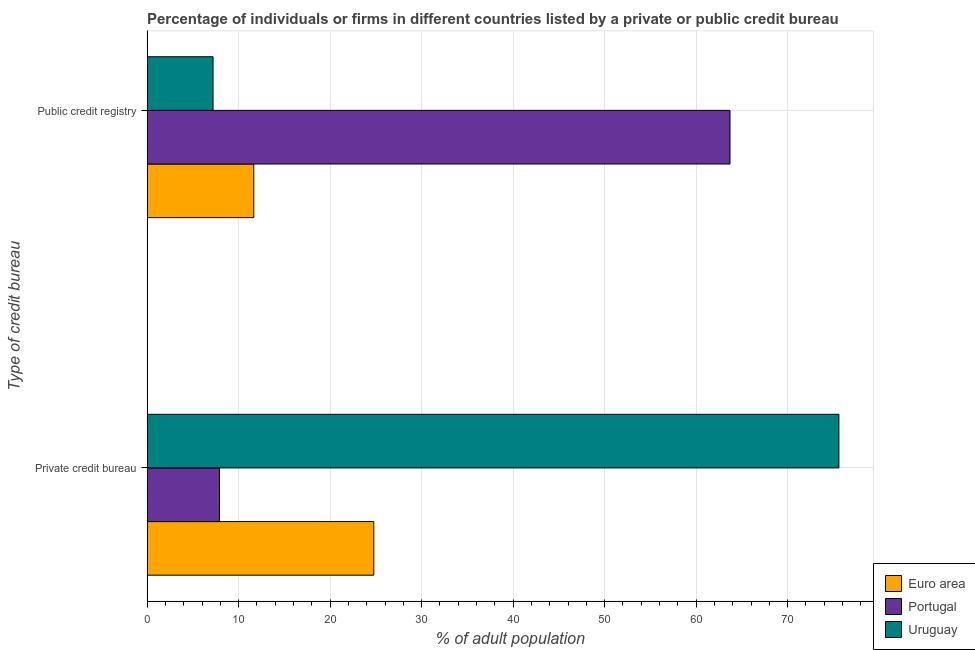Are the number of bars per tick equal to the number of legend labels?
Offer a very short reply. Yes. How many bars are there on the 1st tick from the top?
Make the answer very short. 3. What is the label of the 1st group of bars from the top?
Your answer should be very brief. Public credit registry. What is the percentage of firms listed by public credit bureau in Portugal?
Make the answer very short. 63.7. Across all countries, what is the maximum percentage of firms listed by private credit bureau?
Provide a short and direct response. 75.6. Across all countries, what is the minimum percentage of firms listed by private credit bureau?
Your answer should be compact. 7.9. In which country was the percentage of firms listed by private credit bureau maximum?
Make the answer very short. Uruguay. In which country was the percentage of firms listed by public credit bureau minimum?
Keep it short and to the point. Uruguay. What is the total percentage of firms listed by private credit bureau in the graph?
Ensure brevity in your answer.  108.27. What is the difference between the percentage of firms listed by private credit bureau in Euro area and that in Portugal?
Your response must be concise. 16.87. What is the difference between the percentage of firms listed by public credit bureau in Portugal and the percentage of firms listed by private credit bureau in Euro area?
Your answer should be compact. 38.93. What is the average percentage of firms listed by private credit bureau per country?
Your response must be concise. 36.09. What is the difference between the percentage of firms listed by public credit bureau and percentage of firms listed by private credit bureau in Euro area?
Give a very brief answer. -13.12. What is the ratio of the percentage of firms listed by private credit bureau in Portugal to that in Uruguay?
Give a very brief answer. 0.1. Is the percentage of firms listed by private credit bureau in Uruguay less than that in Euro area?
Offer a very short reply. No. In how many countries, is the percentage of firms listed by private credit bureau greater than the average percentage of firms listed by private credit bureau taken over all countries?
Your answer should be compact. 1. What does the 1st bar from the top in Private credit bureau represents?
Your answer should be very brief. Uruguay. What does the 3rd bar from the bottom in Public credit registry represents?
Ensure brevity in your answer.  Uruguay. How many bars are there?
Your response must be concise. 6. Are all the bars in the graph horizontal?
Ensure brevity in your answer.  Yes. Does the graph contain any zero values?
Make the answer very short. No. Does the graph contain grids?
Offer a terse response. Yes. Where does the legend appear in the graph?
Your response must be concise. Bottom right. How many legend labels are there?
Provide a succinct answer. 3. How are the legend labels stacked?
Your answer should be compact. Vertical. What is the title of the graph?
Your answer should be very brief. Percentage of individuals or firms in different countries listed by a private or public credit bureau. What is the label or title of the X-axis?
Your answer should be compact. % of adult population. What is the label or title of the Y-axis?
Keep it short and to the point. Type of credit bureau. What is the % of adult population in Euro area in Private credit bureau?
Give a very brief answer. 24.77. What is the % of adult population of Portugal in Private credit bureau?
Keep it short and to the point. 7.9. What is the % of adult population of Uruguay in Private credit bureau?
Offer a terse response. 75.6. What is the % of adult population of Euro area in Public credit registry?
Provide a short and direct response. 11.65. What is the % of adult population of Portugal in Public credit registry?
Your response must be concise. 63.7. Across all Type of credit bureau, what is the maximum % of adult population of Euro area?
Offer a terse response. 24.77. Across all Type of credit bureau, what is the maximum % of adult population in Portugal?
Ensure brevity in your answer.  63.7. Across all Type of credit bureau, what is the maximum % of adult population of Uruguay?
Provide a short and direct response. 75.6. Across all Type of credit bureau, what is the minimum % of adult population in Euro area?
Your answer should be very brief. 11.65. What is the total % of adult population of Euro area in the graph?
Offer a very short reply. 36.42. What is the total % of adult population in Portugal in the graph?
Your answer should be compact. 71.6. What is the total % of adult population in Uruguay in the graph?
Provide a short and direct response. 82.8. What is the difference between the % of adult population in Euro area in Private credit bureau and that in Public credit registry?
Your response must be concise. 13.12. What is the difference between the % of adult population in Portugal in Private credit bureau and that in Public credit registry?
Your answer should be very brief. -55.8. What is the difference between the % of adult population of Uruguay in Private credit bureau and that in Public credit registry?
Provide a succinct answer. 68.4. What is the difference between the % of adult population of Euro area in Private credit bureau and the % of adult population of Portugal in Public credit registry?
Your response must be concise. -38.93. What is the difference between the % of adult population of Euro area in Private credit bureau and the % of adult population of Uruguay in Public credit registry?
Ensure brevity in your answer.  17.57. What is the average % of adult population of Euro area per Type of credit bureau?
Offer a very short reply. 18.21. What is the average % of adult population of Portugal per Type of credit bureau?
Your response must be concise. 35.8. What is the average % of adult population in Uruguay per Type of credit bureau?
Give a very brief answer. 41.4. What is the difference between the % of adult population in Euro area and % of adult population in Portugal in Private credit bureau?
Make the answer very short. 16.87. What is the difference between the % of adult population of Euro area and % of adult population of Uruguay in Private credit bureau?
Keep it short and to the point. -50.83. What is the difference between the % of adult population in Portugal and % of adult population in Uruguay in Private credit bureau?
Your response must be concise. -67.7. What is the difference between the % of adult population in Euro area and % of adult population in Portugal in Public credit registry?
Offer a terse response. -52.05. What is the difference between the % of adult population of Euro area and % of adult population of Uruguay in Public credit registry?
Keep it short and to the point. 4.45. What is the difference between the % of adult population in Portugal and % of adult population in Uruguay in Public credit registry?
Your response must be concise. 56.5. What is the ratio of the % of adult population of Euro area in Private credit bureau to that in Public credit registry?
Ensure brevity in your answer.  2.13. What is the ratio of the % of adult population in Portugal in Private credit bureau to that in Public credit registry?
Your answer should be very brief. 0.12. What is the difference between the highest and the second highest % of adult population in Euro area?
Ensure brevity in your answer.  13.12. What is the difference between the highest and the second highest % of adult population of Portugal?
Give a very brief answer. 55.8. What is the difference between the highest and the second highest % of adult population of Uruguay?
Make the answer very short. 68.4. What is the difference between the highest and the lowest % of adult population in Euro area?
Offer a very short reply. 13.12. What is the difference between the highest and the lowest % of adult population of Portugal?
Offer a terse response. 55.8. What is the difference between the highest and the lowest % of adult population in Uruguay?
Provide a short and direct response. 68.4. 